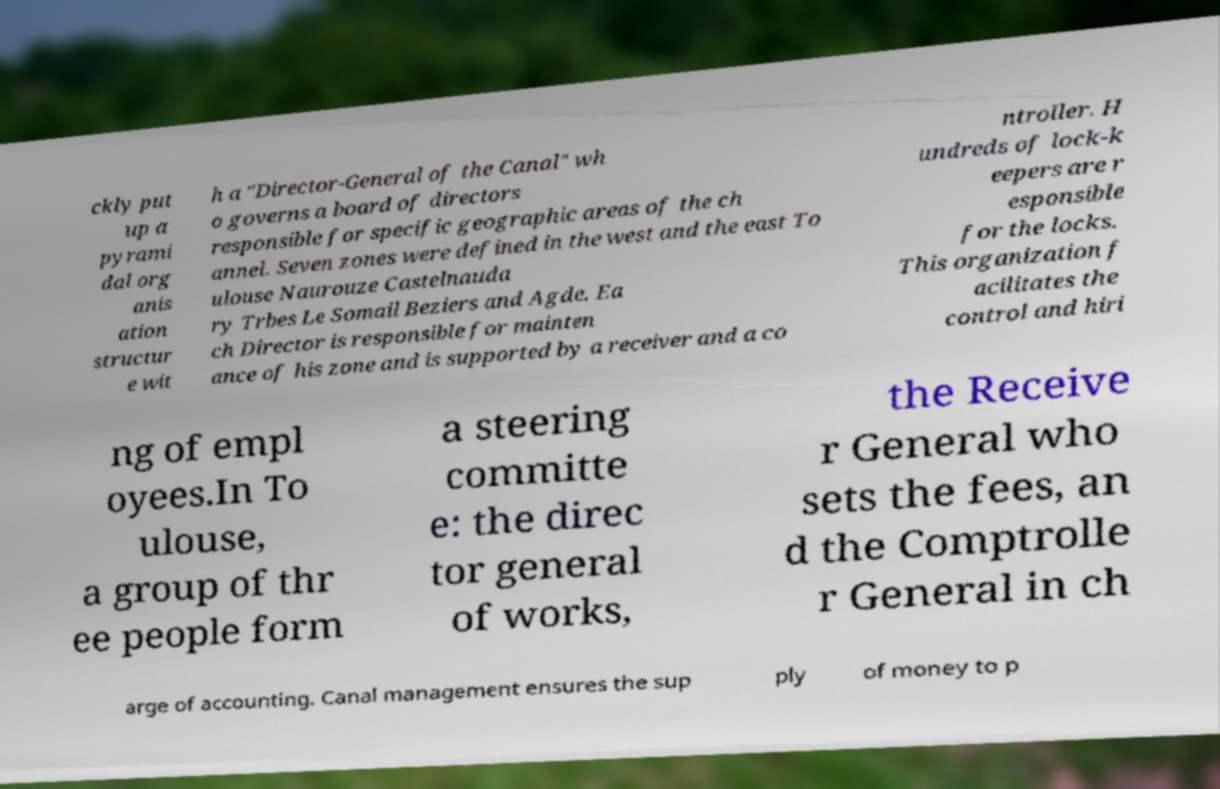Could you extract and type out the text from this image? ckly put up a pyrami dal org anis ation structur e wit h a "Director-General of the Canal" wh o governs a board of directors responsible for specific geographic areas of the ch annel. Seven zones were defined in the west and the east To ulouse Naurouze Castelnauda ry Trbes Le Somail Beziers and Agde. Ea ch Director is responsible for mainten ance of his zone and is supported by a receiver and a co ntroller. H undreds of lock-k eepers are r esponsible for the locks. This organization f acilitates the control and hiri ng of empl oyees.In To ulouse, a group of thr ee people form a steering committe e: the direc tor general of works, the Receive r General who sets the fees, an d the Comptrolle r General in ch arge of accounting. Canal management ensures the sup ply of money to p 